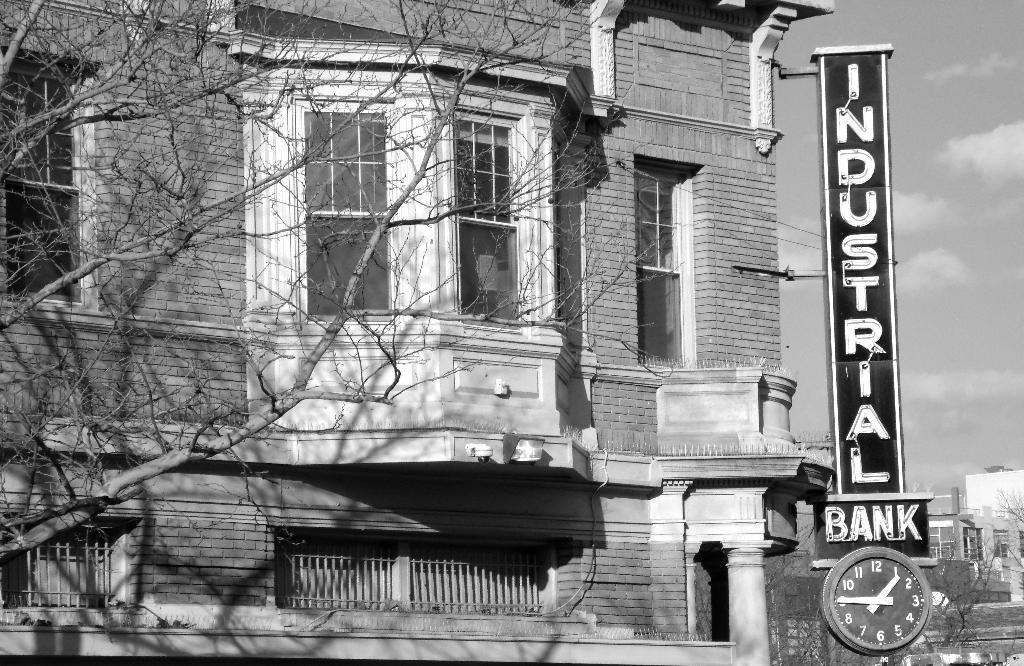What time does the clock say?
Provide a short and direct response. 1:45. 